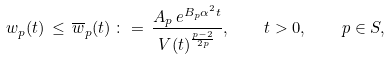Convert formula to latex. <formula><loc_0><loc_0><loc_500><loc_500>w _ { p } ( t ) \, \leq \, \overline { w } _ { p } ( t ) \, \colon = \, \frac { A _ { p } \, e ^ { B _ { p } \alpha ^ { 2 } t } } { V ( t ) ^ { \frac { p - 2 } { 2 p } } } , \quad t > 0 , \quad p \in S ,</formula> 